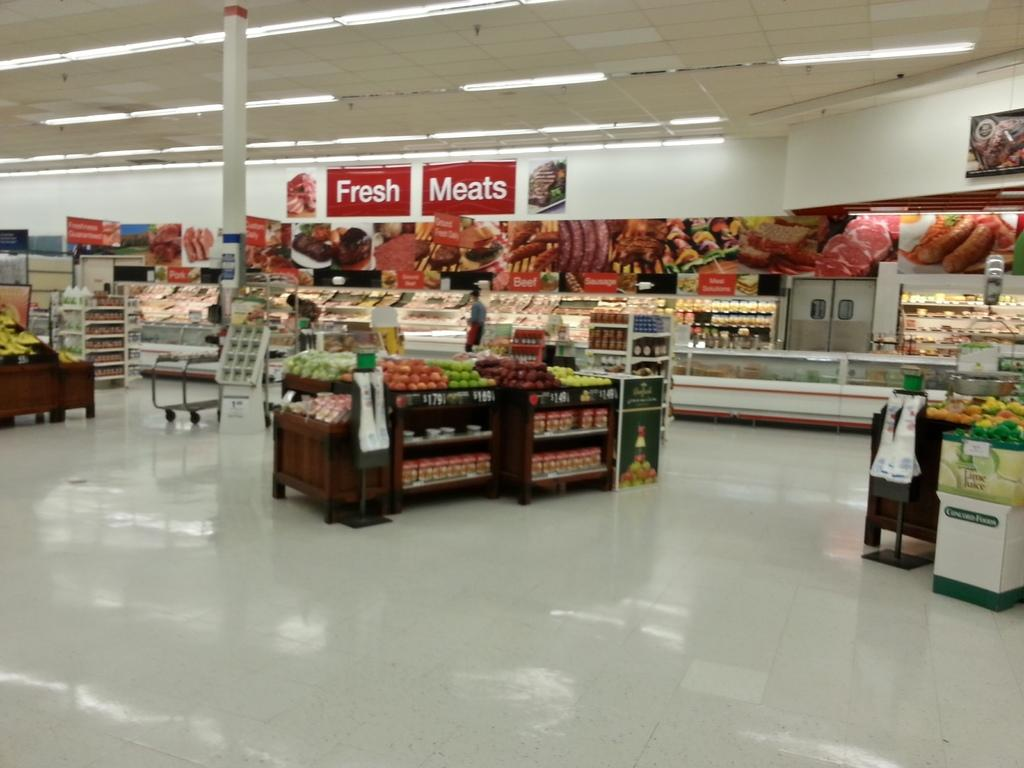<image>
Share a concise interpretation of the image provided. Supermarket showing the Fresh Meats section of the store. 